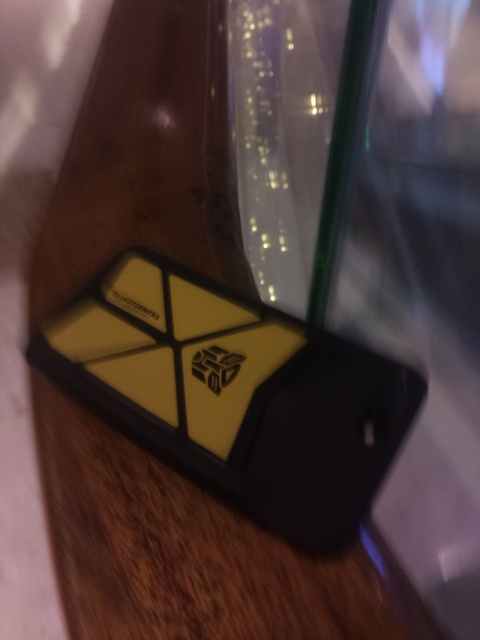Can you comment on the lighting conditions in the photograph and how they affect the object's appearance? The photo appears to be taken under low-light conditions with light sources creating soft reflections on the surface nearby. This ambiance gives the phone a slightly dramatic effect, accentuating its features and highlighting the unique design on its case. The image's exposure level suggests that it was taken indoors, possibly in a social setting such as a cafe or a lounge. 